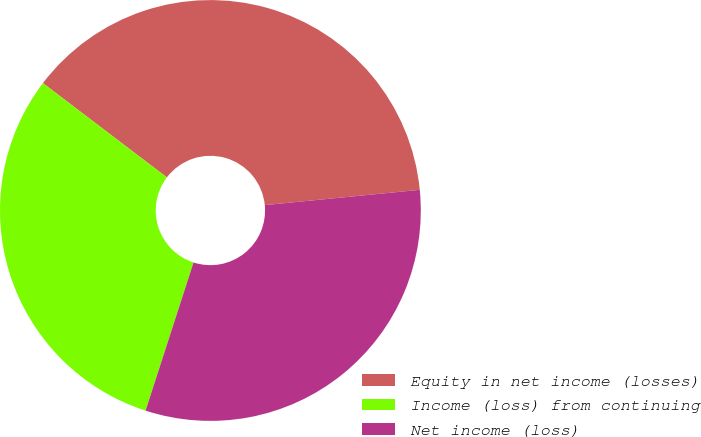Convert chart. <chart><loc_0><loc_0><loc_500><loc_500><pie_chart><fcel>Equity in net income (losses)<fcel>Income (loss) from continuing<fcel>Net income (loss)<nl><fcel>38.09%<fcel>30.36%<fcel>31.55%<nl></chart> 